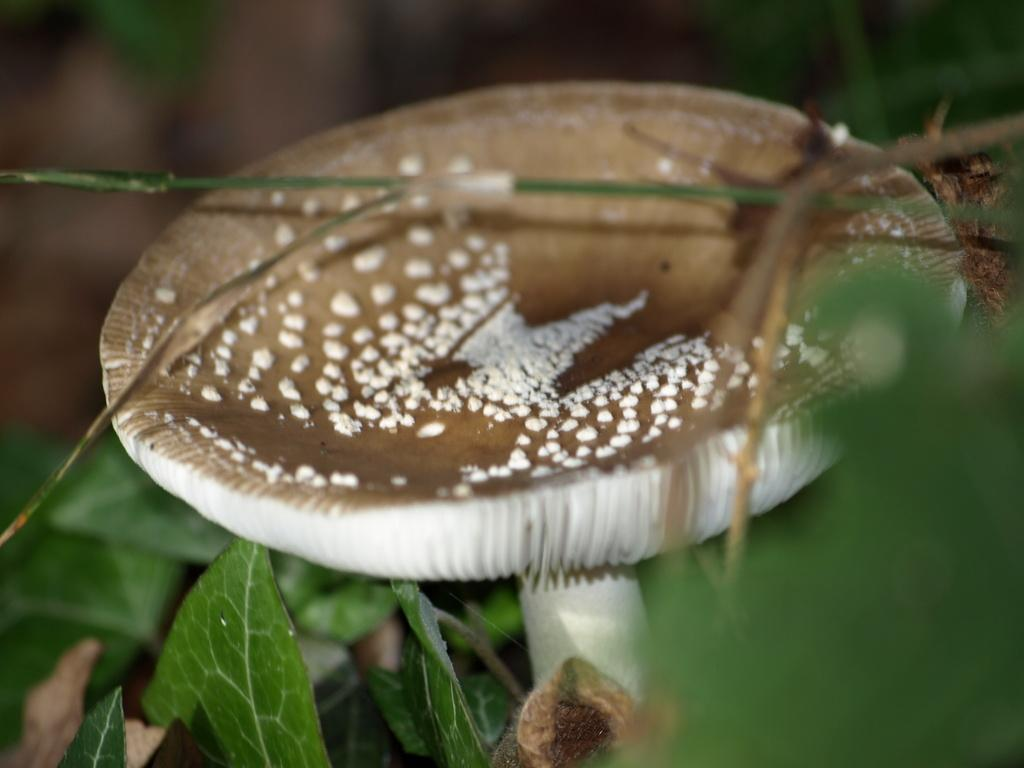What type of fungus can be seen in the image? There is a mushroom in the image. What type of vegetation is present at the bottom of the image? There are plants with leaves at the bottom of the image. How many frogs can be seen sitting on the mushroom in the image? There are no frogs present in the image. 